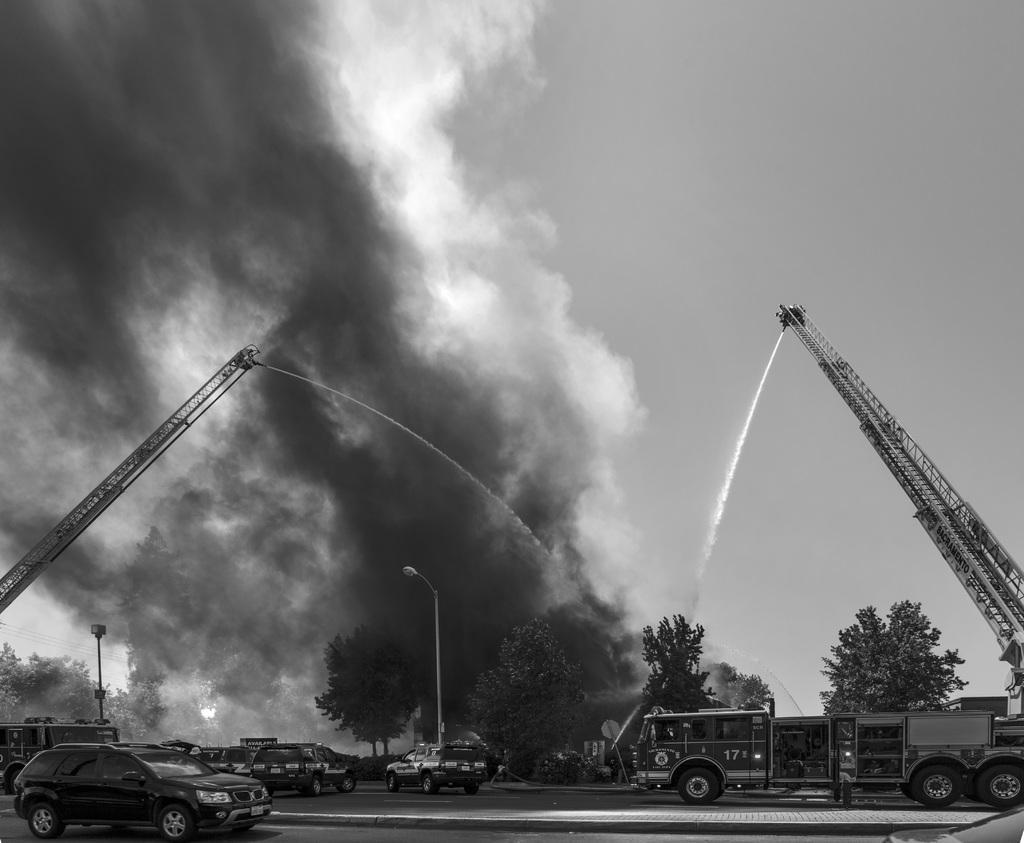Describe this image in one or two sentences. This is a black and white image. In this image we can see the fire engines and some cars on the road. We can also see a street pole, a group of trees, the smoke, a pole and the sky which looks cloudy. 